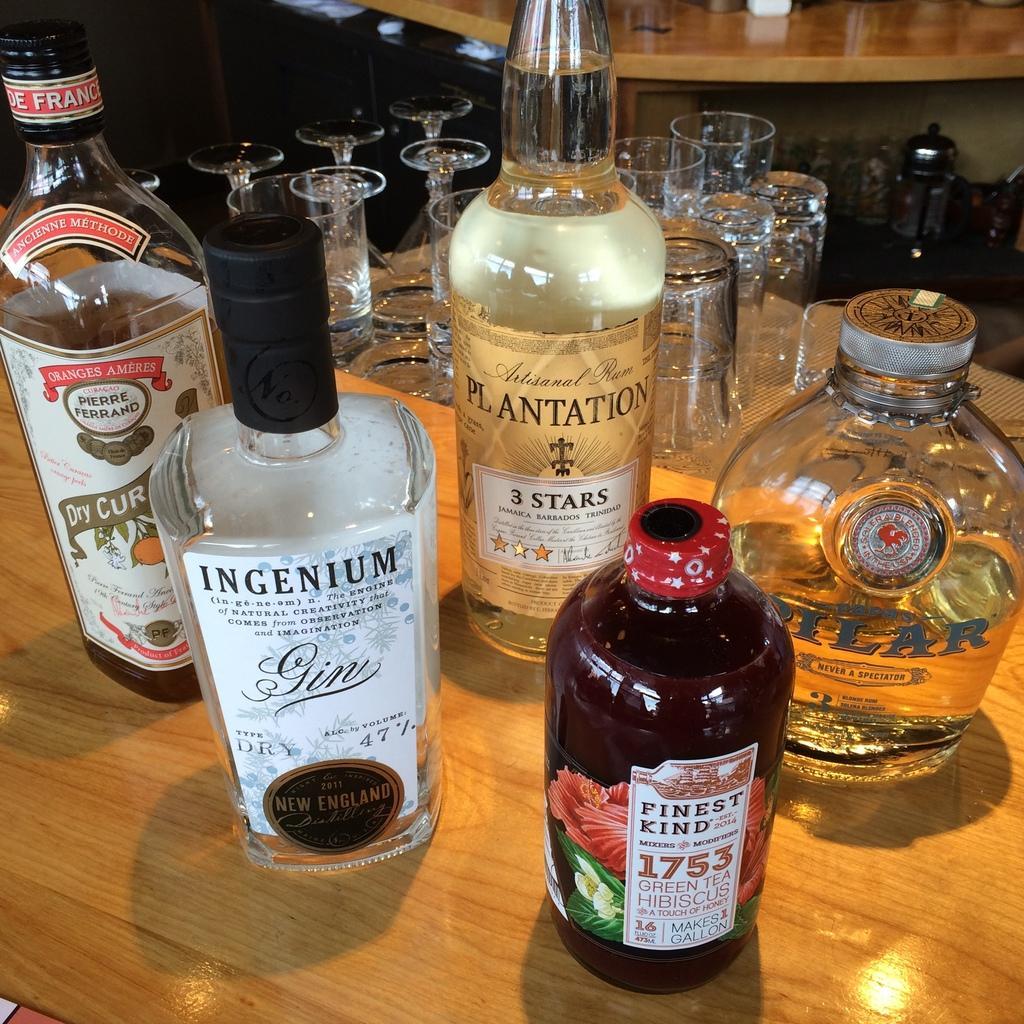In one or two sentences, can you explain what this image depicts? There are different type of wine bottles placed on the table. Behind them there are some glasses here. 